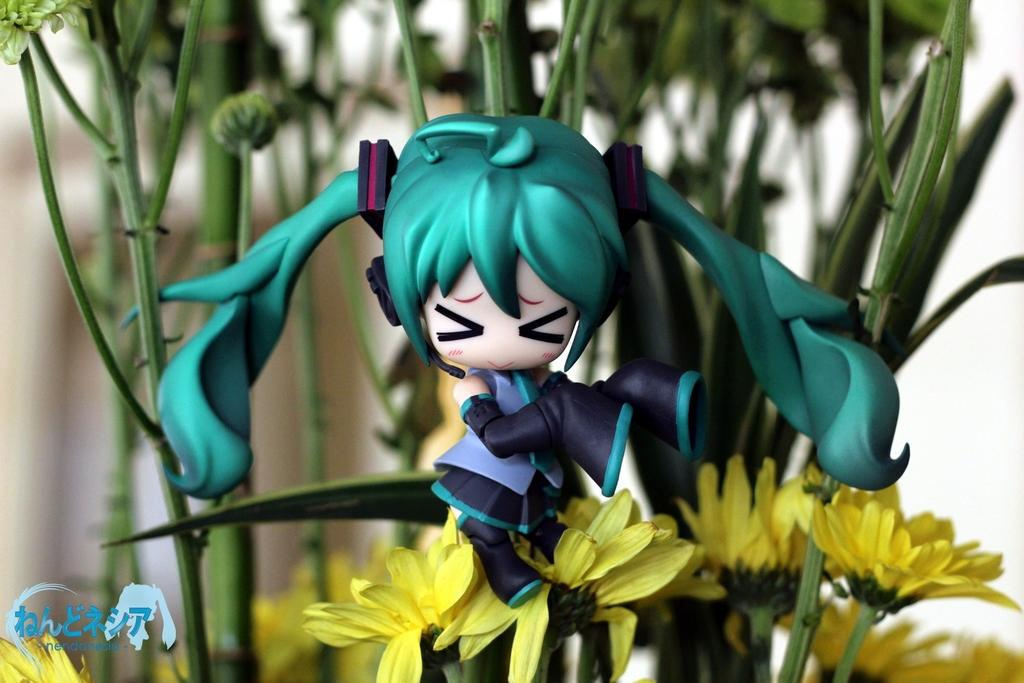What types of living organisms can be seen in the image? Plants and flowers are visible in the image. What other object can be seen in the image? There is a doll in the image. Can you describe the watermark in the image? There is a watermark in the bottom left corner of the image. How would you describe the background of the image? The background of the image is blurred. What type of committee is meeting in the image? There is no committee meeting in the image; it features plants, flowers, a doll, and a watermark. Can you describe the circle in the image? There is no circle present in the image. 